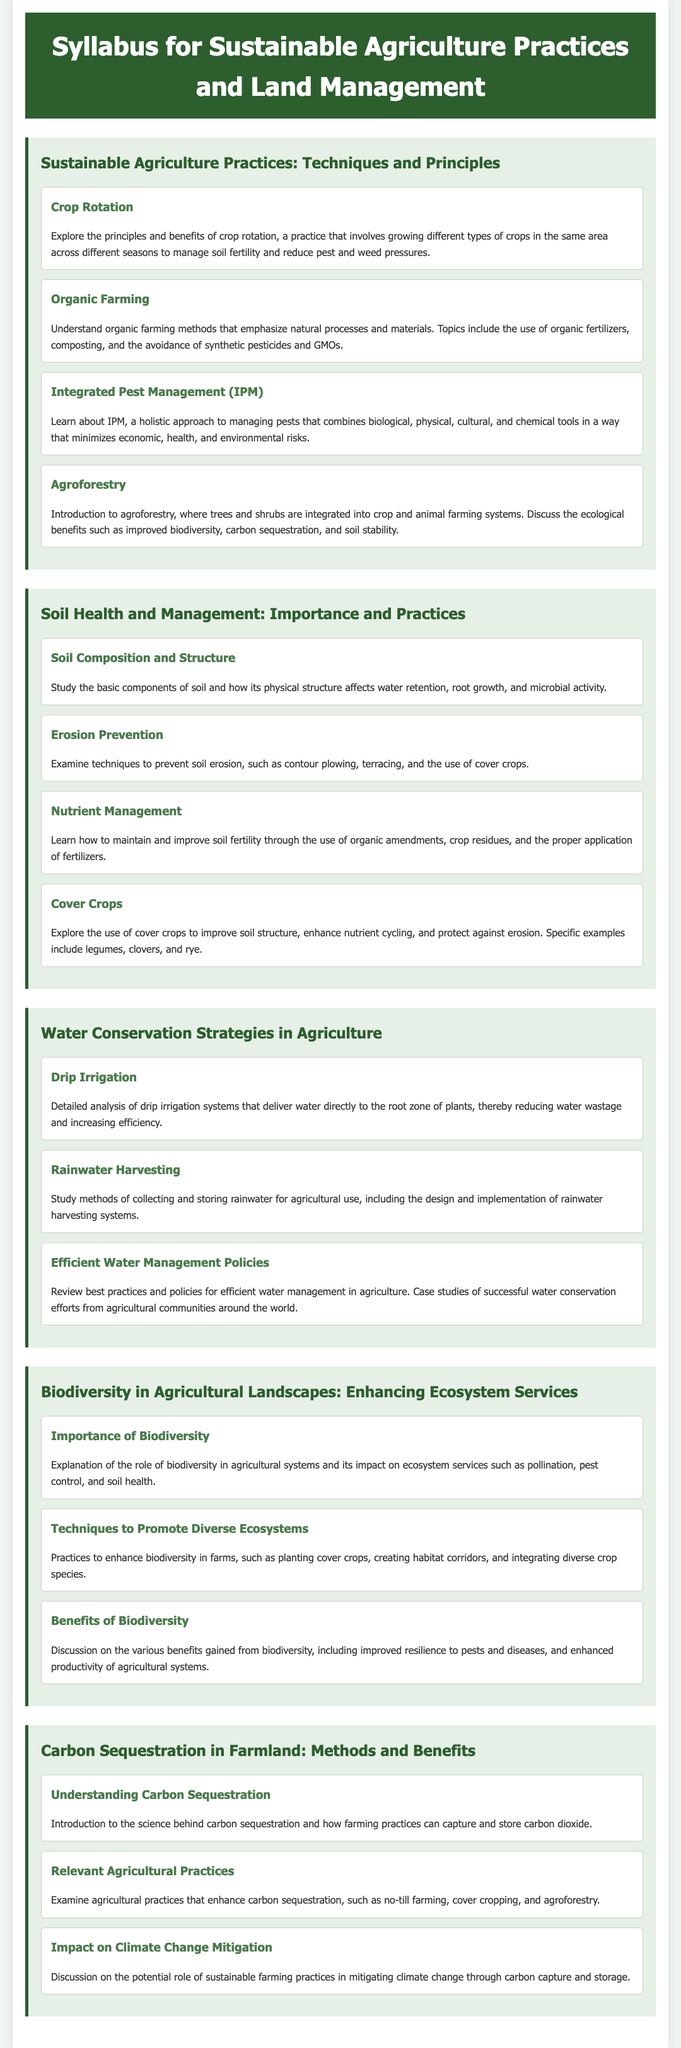What is the title of the syllabus? The title clearly states the focus of the syllabus, which is "Syllabus for Sustainable Agriculture Practices and Land Management."
Answer: Syllabus for Sustainable Agriculture Practices and Land Management What is the first topic under Sustainable Agriculture Practices? The first topic listed in the module is "Crop Rotation," which emphasizes the principles and benefits of this practice.
Answer: Crop Rotation Which water conservation strategy uses a specific type of irrigation system? The document mentions "Drip Irrigation" as a technique that delivers water directly to the plants' root zone.
Answer: Drip Irrigation What are two practices to enhance biodiversity in agricultural landscapes? The document outlines techniques such as "planting cover crops" and "creating habitat corridors."
Answer: Planting cover crops, creating habitat corridors What is the impact discussed in the module on Carbon Sequestration? The document refers to the role of sustainable farming practices in mitigating climate change.
Answer: Mitigating climate change How many topics are included under Soil Health and Management? There are four distinct topics covered: Soil Composition and Structure, Erosion Prevention, Nutrient Management, and Cover Crops.
Answer: Four What farming approach combines various methods to control pests? The syllabus describes "Integrated Pest Management (IPM)" as a holistic approach to pest management.
Answer: Integrated Pest Management What is one agricultural practice that enhances carbon sequestration? The document mentions "no-till farming" as a relevant agricultural practice for enhancing carbon sequestration.
Answer: No-till farming Which method of water conservation involves collecting and storing rainwater? The "Rainwater Harvesting" strategy focuses on methods for collecting and storing rainwater for agricultural use.
Answer: Rainwater Harvesting 